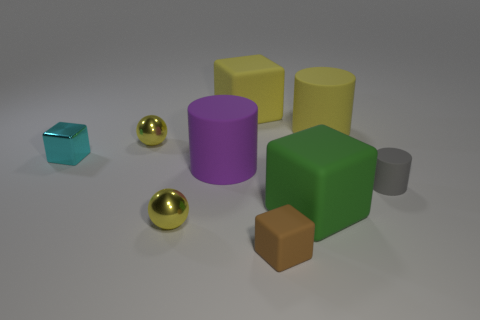Is the number of green matte objects that are to the right of the gray cylinder less than the number of yellow matte things?
Ensure brevity in your answer.  Yes. The brown object is what shape?
Your response must be concise. Cube. What is the size of the metallic object that is in front of the large purple matte object?
Your answer should be very brief. Small. What color is the shiny cube that is the same size as the gray matte object?
Offer a terse response. Cyan. Is there a big cylinder that has the same color as the small rubber cube?
Provide a short and direct response. No. Are there fewer objects that are on the left side of the green cube than large rubber blocks in front of the yellow rubber cylinder?
Provide a succinct answer. No. The big thing that is both in front of the big yellow cube and behind the small metal block is made of what material?
Offer a terse response. Rubber. Does the large purple matte thing have the same shape as the tiny metallic object that is in front of the large green matte thing?
Make the answer very short. No. How many other objects are there of the same size as the purple cylinder?
Give a very brief answer. 3. Are there more small cyan metal blocks than objects?
Your answer should be compact. No. 